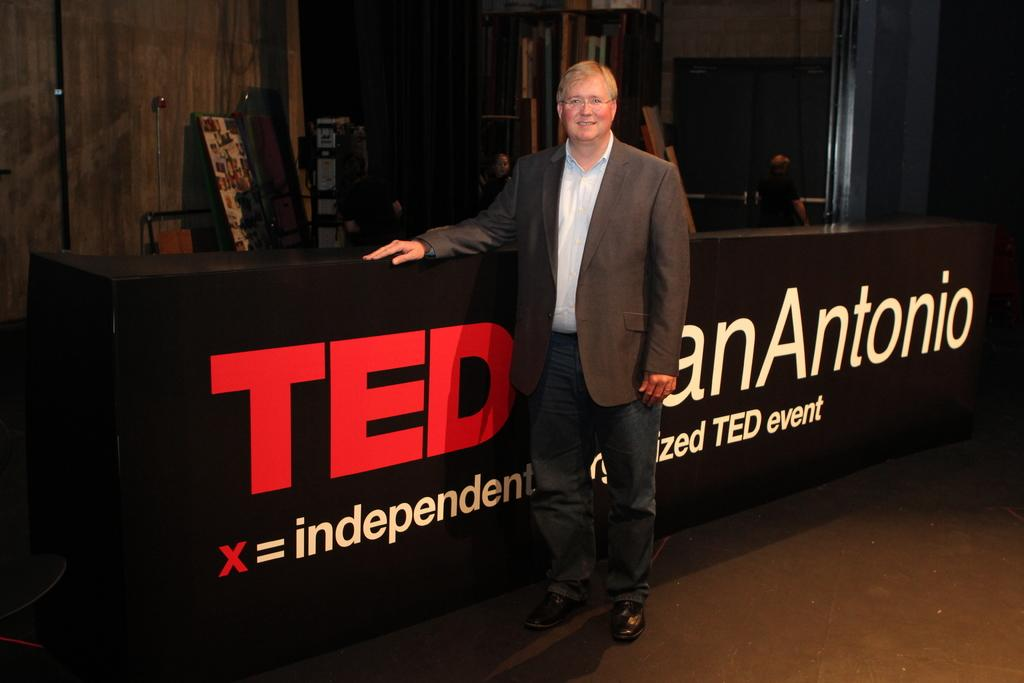What is the main subject of the image? There is a man standing in the image. Can you describe the man's appearance? The man is wearing spectacles. What object can be seen in the image besides the man? There is a table in the image. What is written on the table? Text is written on the table. What can be seen in the background of the image? There is a wall, a frame, a board, and a person in the background of the image. What type of pen is the secretary using in the image? There is no secretary or pen present in the image. 